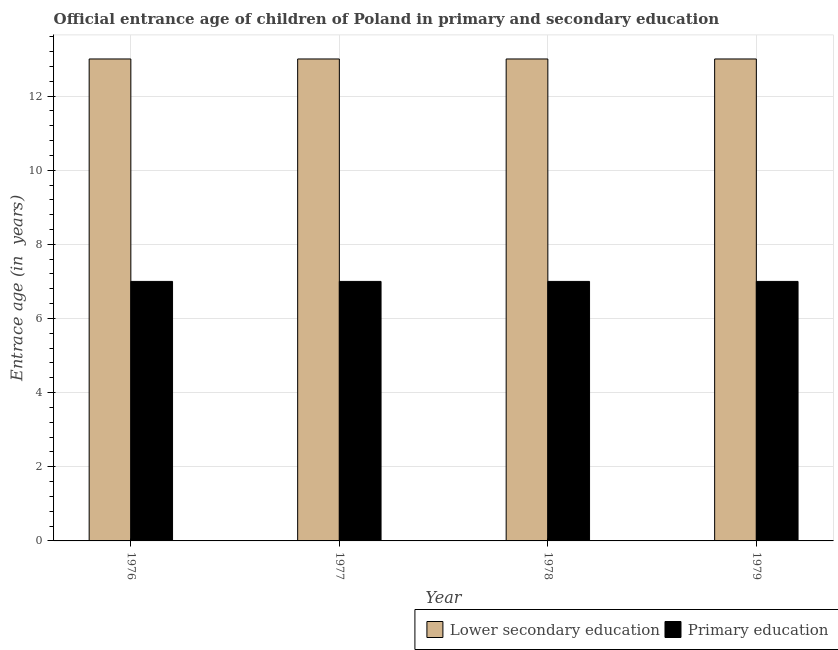How many groups of bars are there?
Your response must be concise. 4. How many bars are there on the 3rd tick from the left?
Your response must be concise. 2. How many bars are there on the 2nd tick from the right?
Offer a very short reply. 2. What is the label of the 2nd group of bars from the left?
Your answer should be very brief. 1977. In how many cases, is the number of bars for a given year not equal to the number of legend labels?
Your response must be concise. 0. What is the entrance age of children in lower secondary education in 1978?
Offer a terse response. 13. Across all years, what is the maximum entrance age of chiildren in primary education?
Provide a succinct answer. 7. Across all years, what is the minimum entrance age of chiildren in primary education?
Your response must be concise. 7. In which year was the entrance age of chiildren in primary education maximum?
Keep it short and to the point. 1976. In which year was the entrance age of chiildren in primary education minimum?
Provide a succinct answer. 1976. What is the total entrance age of children in lower secondary education in the graph?
Ensure brevity in your answer.  52. What is the difference between the entrance age of chiildren in primary education in 1979 and the entrance age of children in lower secondary education in 1977?
Provide a succinct answer. 0. What is the average entrance age of chiildren in primary education per year?
Offer a very short reply. 7. In how many years, is the entrance age of children in lower secondary education greater than 4 years?
Make the answer very short. 4. What is the ratio of the entrance age of children in lower secondary education in 1977 to that in 1979?
Provide a short and direct response. 1. Is the difference between the entrance age of children in lower secondary education in 1977 and 1978 greater than the difference between the entrance age of chiildren in primary education in 1977 and 1978?
Ensure brevity in your answer.  No. What is the difference between the highest and the second highest entrance age of chiildren in primary education?
Your response must be concise. 0. Is the sum of the entrance age of chiildren in primary education in 1976 and 1977 greater than the maximum entrance age of children in lower secondary education across all years?
Offer a terse response. Yes. What does the 1st bar from the left in 1978 represents?
Your answer should be very brief. Lower secondary education. How many years are there in the graph?
Provide a short and direct response. 4. Are the values on the major ticks of Y-axis written in scientific E-notation?
Offer a terse response. No. Does the graph contain any zero values?
Your answer should be compact. No. Where does the legend appear in the graph?
Provide a short and direct response. Bottom right. How are the legend labels stacked?
Keep it short and to the point. Horizontal. What is the title of the graph?
Your answer should be very brief. Official entrance age of children of Poland in primary and secondary education. Does "Unregistered firms" appear as one of the legend labels in the graph?
Make the answer very short. No. What is the label or title of the Y-axis?
Ensure brevity in your answer.  Entrace age (in  years). What is the Entrace age (in  years) of Lower secondary education in 1977?
Your answer should be compact. 13. What is the Entrace age (in  years) in Primary education in 1977?
Your answer should be compact. 7. What is the Entrace age (in  years) in Lower secondary education in 1978?
Ensure brevity in your answer.  13. What is the Entrace age (in  years) of Lower secondary education in 1979?
Your answer should be compact. 13. Across all years, what is the maximum Entrace age (in  years) in Lower secondary education?
Your response must be concise. 13. Across all years, what is the maximum Entrace age (in  years) in Primary education?
Keep it short and to the point. 7. Across all years, what is the minimum Entrace age (in  years) in Primary education?
Provide a short and direct response. 7. What is the total Entrace age (in  years) of Primary education in the graph?
Offer a very short reply. 28. What is the difference between the Entrace age (in  years) of Lower secondary education in 1976 and that in 1977?
Your response must be concise. 0. What is the difference between the Entrace age (in  years) of Lower secondary education in 1976 and that in 1979?
Keep it short and to the point. 0. What is the difference between the Entrace age (in  years) in Lower secondary education in 1977 and that in 1978?
Offer a very short reply. 0. What is the difference between the Entrace age (in  years) of Primary education in 1977 and that in 1979?
Give a very brief answer. 0. What is the difference between the Entrace age (in  years) of Primary education in 1978 and that in 1979?
Make the answer very short. 0. What is the difference between the Entrace age (in  years) of Lower secondary education in 1976 and the Entrace age (in  years) of Primary education in 1977?
Make the answer very short. 6. What is the difference between the Entrace age (in  years) of Lower secondary education in 1976 and the Entrace age (in  years) of Primary education in 1978?
Offer a very short reply. 6. What is the difference between the Entrace age (in  years) of Lower secondary education in 1976 and the Entrace age (in  years) of Primary education in 1979?
Ensure brevity in your answer.  6. What is the difference between the Entrace age (in  years) of Lower secondary education in 1977 and the Entrace age (in  years) of Primary education in 1978?
Ensure brevity in your answer.  6. What is the difference between the Entrace age (in  years) of Lower secondary education in 1977 and the Entrace age (in  years) of Primary education in 1979?
Keep it short and to the point. 6. What is the difference between the Entrace age (in  years) of Lower secondary education in 1978 and the Entrace age (in  years) of Primary education in 1979?
Ensure brevity in your answer.  6. What is the average Entrace age (in  years) of Lower secondary education per year?
Ensure brevity in your answer.  13. What is the average Entrace age (in  years) of Primary education per year?
Provide a short and direct response. 7. In the year 1976, what is the difference between the Entrace age (in  years) in Lower secondary education and Entrace age (in  years) in Primary education?
Keep it short and to the point. 6. In the year 1978, what is the difference between the Entrace age (in  years) in Lower secondary education and Entrace age (in  years) in Primary education?
Your answer should be compact. 6. In the year 1979, what is the difference between the Entrace age (in  years) in Lower secondary education and Entrace age (in  years) in Primary education?
Offer a very short reply. 6. What is the ratio of the Entrace age (in  years) of Lower secondary education in 1976 to that in 1977?
Give a very brief answer. 1. What is the ratio of the Entrace age (in  years) of Primary education in 1976 to that in 1977?
Your answer should be compact. 1. What is the ratio of the Entrace age (in  years) in Lower secondary education in 1976 to that in 1978?
Make the answer very short. 1. What is the ratio of the Entrace age (in  years) in Primary education in 1976 to that in 1978?
Your answer should be very brief. 1. What is the ratio of the Entrace age (in  years) in Primary education in 1977 to that in 1978?
Offer a very short reply. 1. What is the ratio of the Entrace age (in  years) of Primary education in 1977 to that in 1979?
Your answer should be compact. 1. What is the ratio of the Entrace age (in  years) of Primary education in 1978 to that in 1979?
Provide a short and direct response. 1. What is the difference between the highest and the second highest Entrace age (in  years) in Lower secondary education?
Provide a short and direct response. 0. What is the difference between the highest and the lowest Entrace age (in  years) in Lower secondary education?
Offer a terse response. 0. 